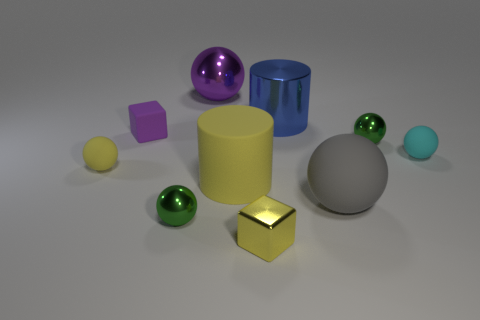Can you identify the shapes and colors of the objects in the image? Certainly! In the image, there's a variety of geometric shapes; there's a large yellow cylinder, a medium-sized blue cylinder, a shiny metallic cube, a large grey sphere, a small green sphere, a small yellow sphere, and a purple cube. The colors include yellow, blue, metallic (which reflects its surroundings), grey, green, and purple. 